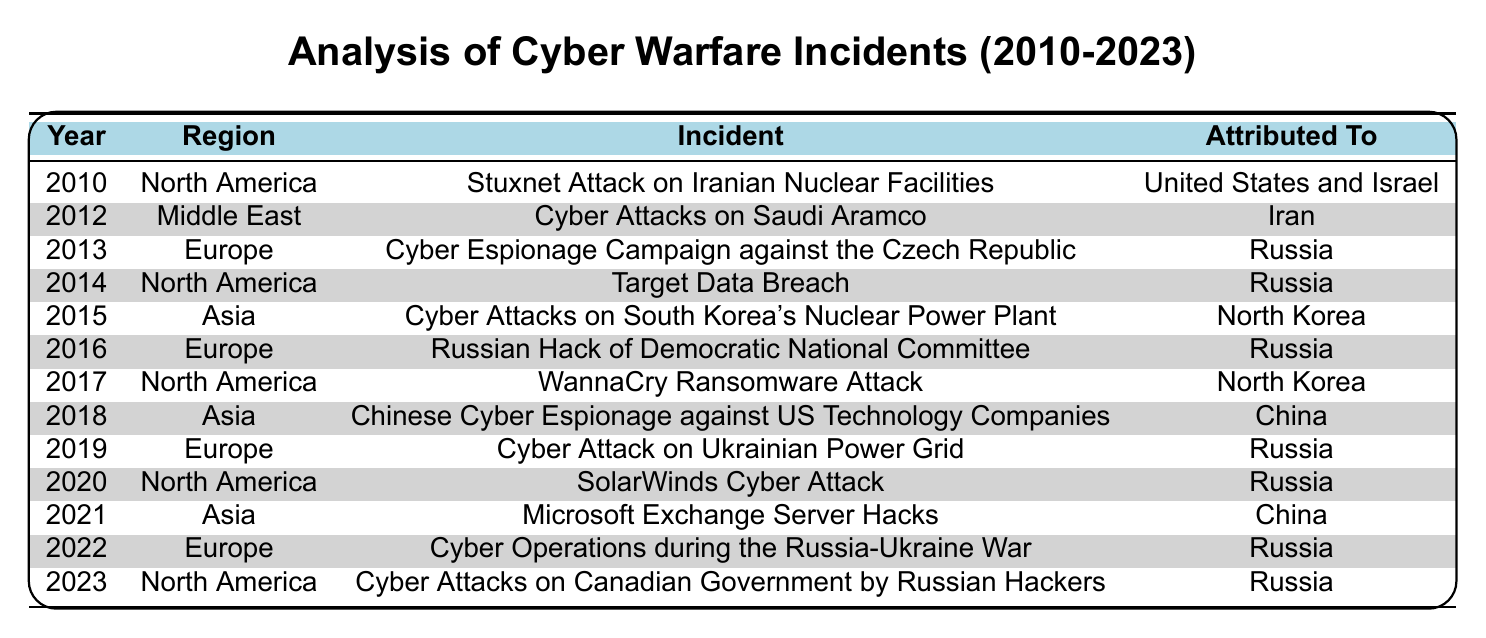What was the first cyber warfare incident reported in the table? The first incident listed in chronological order is the "Stuxnet Attack on Iranian Nuclear Facilities," which occurred in 2010.
Answer: Stuxnet Attack on Iranian Nuclear Facilities How many incidents were attributed to Russia in Europe? By reviewing the entries for Europe, the incidents attributed to Russia are those in 2013, 2016, 2019, and 2022, totaling four incidents.
Answer: 4 incidents Which region experienced the most cyber warfare incidents? Counting incidents by region shows North America has 5 incidents (2010, 2014, 2017, 2020, 2023), Europe has 4 incidents (2013, 2016, 2019, 2022), Asia has 3 incidents (2015, 2018, 2021), and the Middle East has 1 incident (2012). North America has the highest total.
Answer: North America Was there any incident attributed to China? There are two incidents attributed to China, both occurring in 2018 and 2021, confirming the presence of such incidents.
Answer: Yes Identify the incident from Asia that was attributed to North Korea. Checking the Asia incidents, the "Cyber Attacks on South Korea's Nuclear Power Plant" in 2015 is the one attributed to North Korea.
Answer: Cyber Attacks on South Korea's Nuclear Power Plant In which year did Russia first appear as the attributed actor in this table? Looking through the incidents, Russia first appears in the "Cyber Espionage Campaign against the Czech Republic" in 2013, marking its initial attribution in this data.
Answer: 2013 What is the total number of cyber warfare incidents attributed to North Korea? The incidents attributed to North Korea are in 2015 (Cyber Attacks on South Korea's Nuclear Power Plant) and 2017 (WannaCry Ransomware Attack), which total two incidents.
Answer: 2 incidents How many incidents occurred in North America after 2015? The incidents in North America after 2015 are from 2017 (WannaCry), 2020 (SolarWinds), and 2023 (Cyber Attacks on Canadian Government), which total three incidents.
Answer: 3 incidents Was there a relationship between the years of incidents and the regions affected? The table shows multiple incidents across regions, suggesting a trend where certain regions are more affected in specific years, especially in North America and Europe; thus, indicating a relationship exists.
Answer: Yes How many different state actors are attributed to the cyber warfare incidents listed? The distinct actors identified are the United States, Israel, Iran, North Korea, Russia, and China, totaling six different state actors included in the incidents.
Answer: 6 actors 